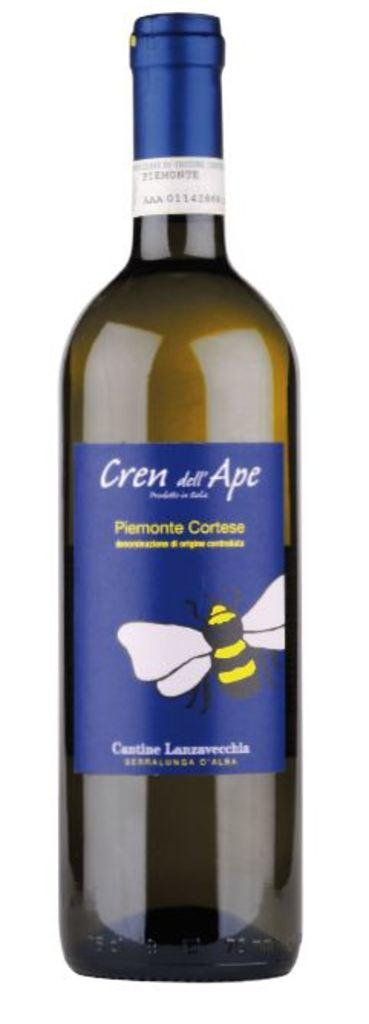<image>
Give a short and clear explanation of the subsequent image. The blue label on the wine was richly colored. 